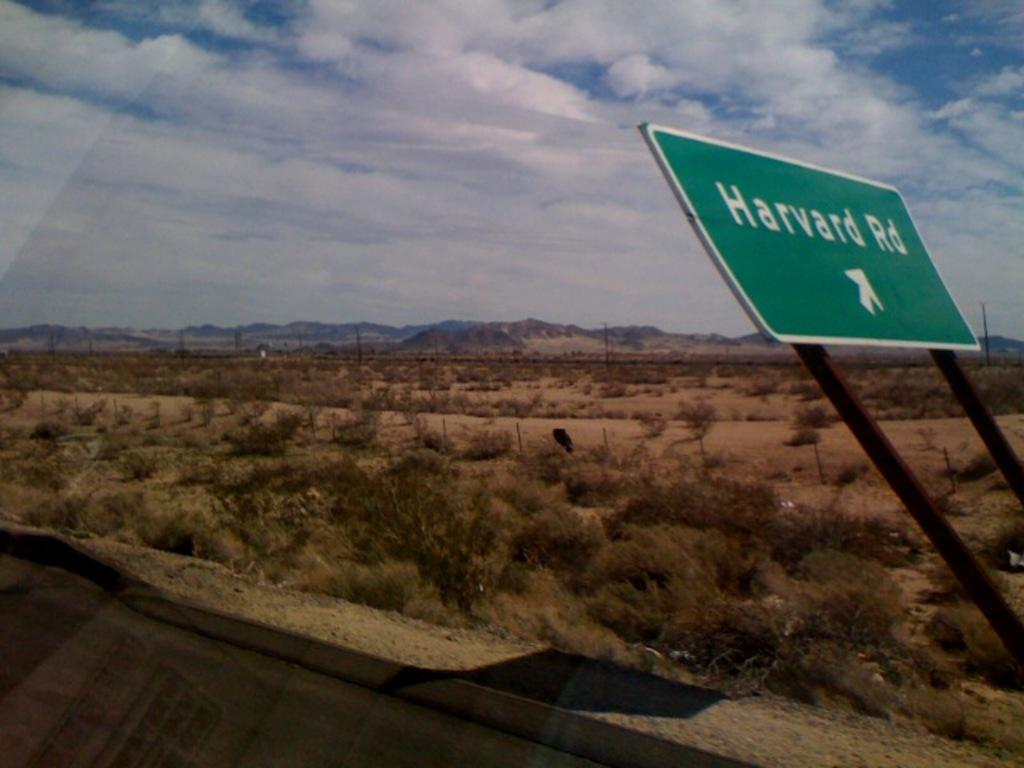Provide a one-sentence caption for the provided image. Harvard Road is off to the right through the desert. 